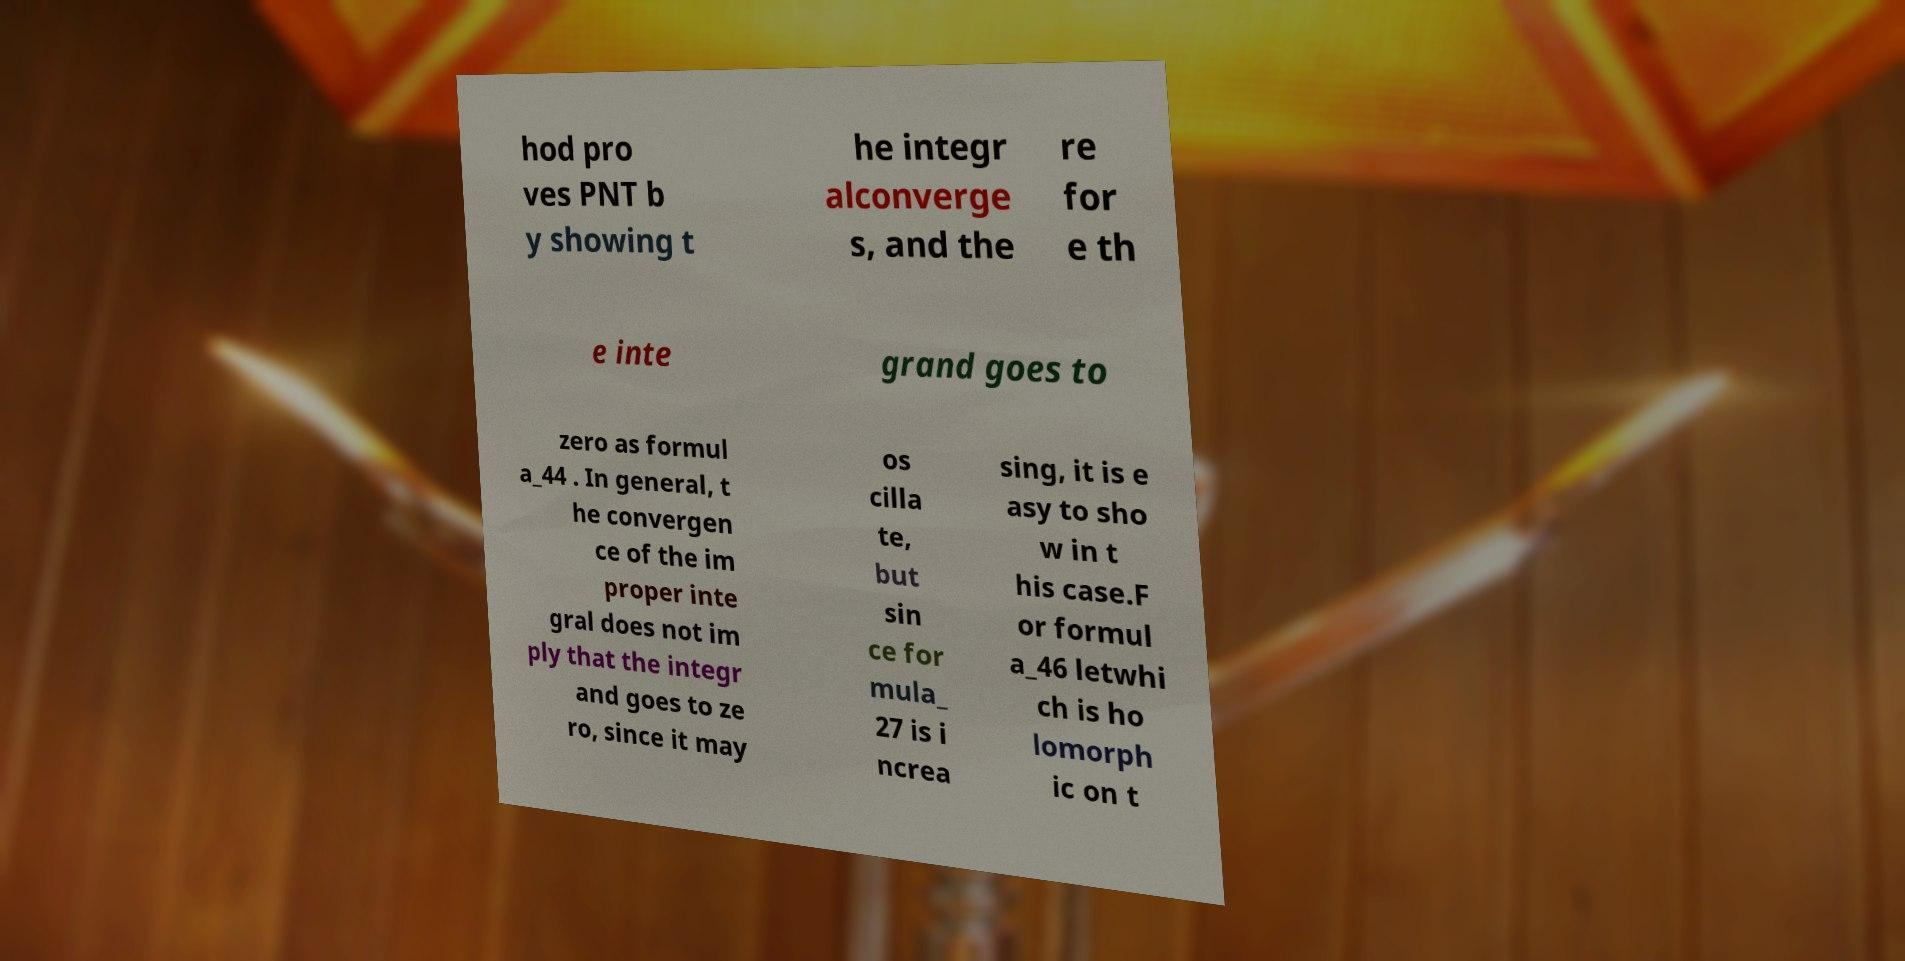Can you accurately transcribe the text from the provided image for me? hod pro ves PNT b y showing t he integr alconverge s, and the re for e th e inte grand goes to zero as formul a_44 . In general, t he convergen ce of the im proper inte gral does not im ply that the integr and goes to ze ro, since it may os cilla te, but sin ce for mula_ 27 is i ncrea sing, it is e asy to sho w in t his case.F or formul a_46 letwhi ch is ho lomorph ic on t 